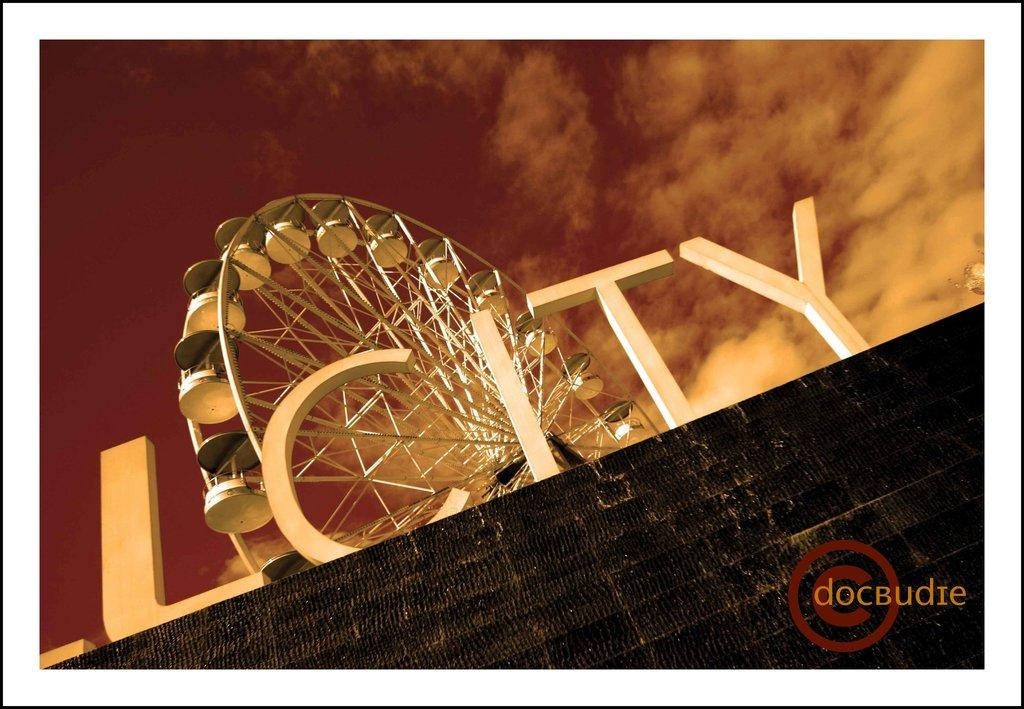What is the main subject in the center of the image? There is an object in the center of the image. Can you describe any written information in the image? There is text in the image, and there is also text in the bottom right corner. What type of background is visible at the bottom of the image? There is a wall at the bottom of the image. What part of the natural environment is visible at the top of the image? The sky is visible at the top of the image. What month is depicted in the image? There is no month depicted in the image; it does not contain any information about a specific time or date. 